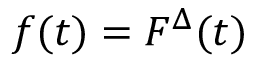<formula> <loc_0><loc_0><loc_500><loc_500>f ( t ) = F ^ { \Delta } ( t )</formula> 